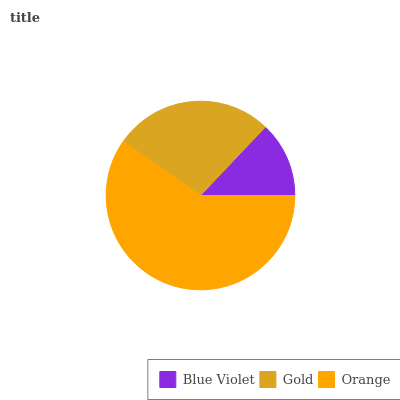Is Blue Violet the minimum?
Answer yes or no. Yes. Is Orange the maximum?
Answer yes or no. Yes. Is Gold the minimum?
Answer yes or no. No. Is Gold the maximum?
Answer yes or no. No. Is Gold greater than Blue Violet?
Answer yes or no. Yes. Is Blue Violet less than Gold?
Answer yes or no. Yes. Is Blue Violet greater than Gold?
Answer yes or no. No. Is Gold less than Blue Violet?
Answer yes or no. No. Is Gold the high median?
Answer yes or no. Yes. Is Gold the low median?
Answer yes or no. Yes. Is Blue Violet the high median?
Answer yes or no. No. Is Blue Violet the low median?
Answer yes or no. No. 